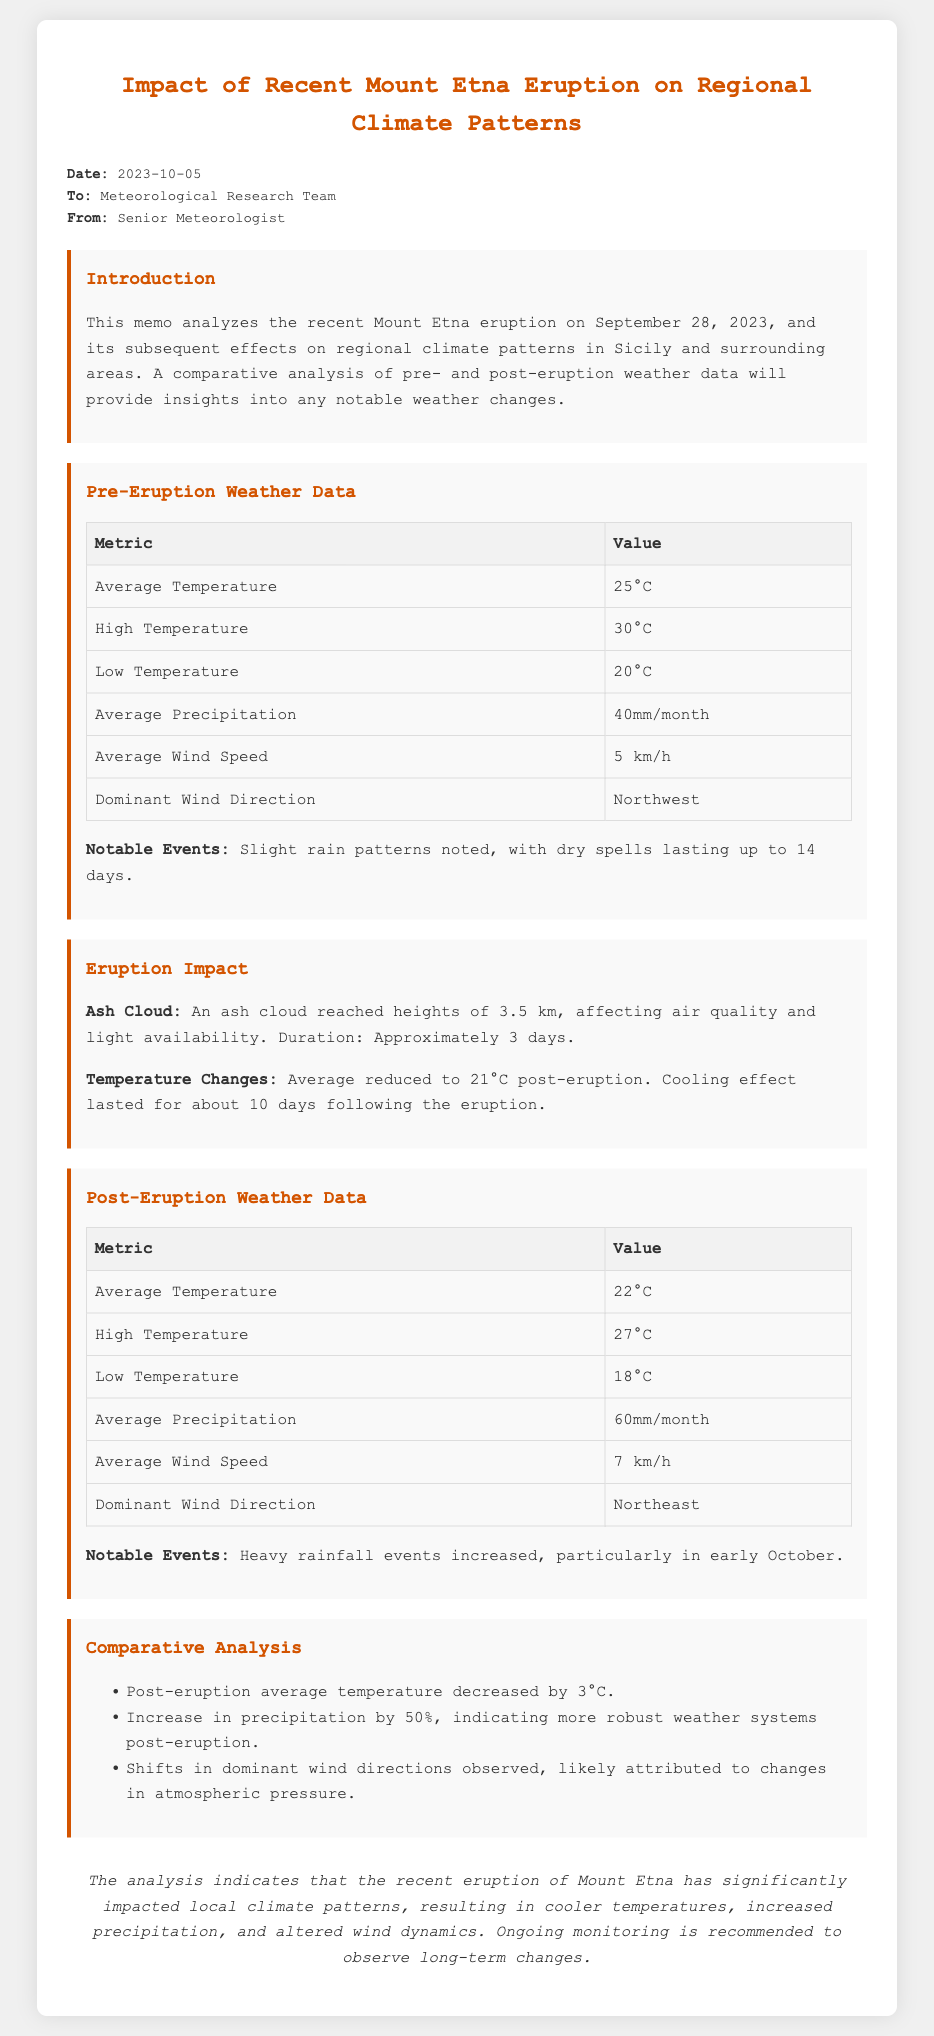What was the eruption date of Mount Etna? The document states that the eruption of Mount Etna occurred on September 28, 2023.
Answer: September 28, 2023 What was the average temperature before the eruption? The average temperature prior to the eruption was 25°C, as indicated in the pre-eruption weather data section.
Answer: 25°C What was the high temperature recorded post-eruption? The post-eruption weather data shows that the high temperature recorded was 27°C.
Answer: 27°C By how much did the average temperature decrease post-eruption? The comparative analysis section mentions that the post-eruption average temperature decreased by 3°C.
Answer: 3°C What was the dominant wind direction before the eruption? According to the pre-eruption data, the dominant wind direction was Northwest.
Answer: Northwest What increase in average precipitation was noted post-eruption? The document indicates an increase in average precipitation by 50% post-eruption.
Answer: 50% What effect did the ash cloud have on temperature? The memo states that the average temperature was reduced to 21°C after the eruption due to the ash cloud.
Answer: 21°C What is recommended following the analysis of the eruption's effects? The conclusion of the memo recommends ongoing monitoring to observe long-term changes resulting from the eruption.
Answer: Ongoing monitoring 